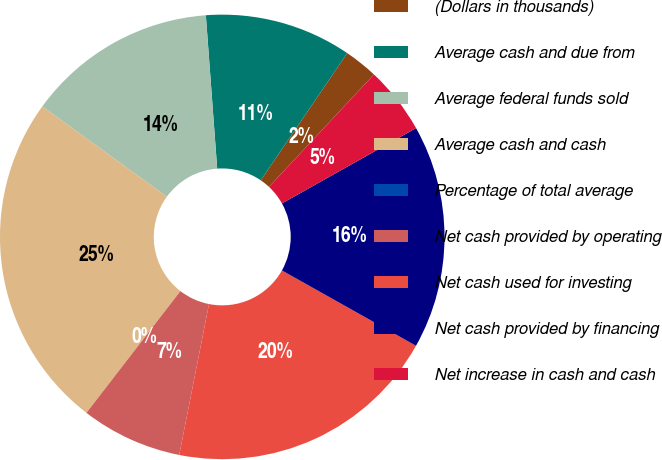<chart> <loc_0><loc_0><loc_500><loc_500><pie_chart><fcel>(Dollars in thousands)<fcel>Average cash and due from<fcel>Average federal funds sold<fcel>Average cash and cash<fcel>Percentage of total average<fcel>Net cash provided by operating<fcel>Net cash used for investing<fcel>Net cash provided by financing<fcel>Net increase in cash and cash<nl><fcel>2.45%<fcel>10.68%<fcel>13.84%<fcel>24.52%<fcel>0.0%<fcel>7.36%<fcel>19.95%<fcel>16.29%<fcel>4.9%<nl></chart> 